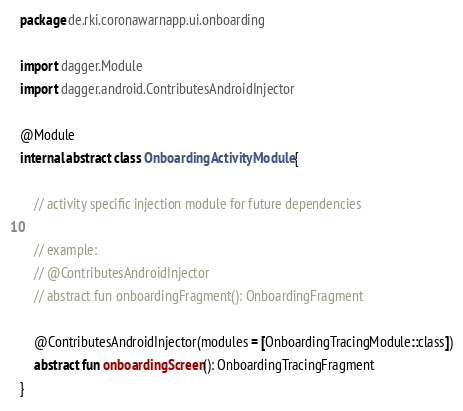Convert code to text. <code><loc_0><loc_0><loc_500><loc_500><_Kotlin_>package de.rki.coronawarnapp.ui.onboarding

import dagger.Module
import dagger.android.ContributesAndroidInjector

@Module
internal abstract class OnboardingActivityModule {

    // activity specific injection module for future dependencies

    // example:
    // @ContributesAndroidInjector
    // abstract fun onboardingFragment(): OnboardingFragment

    @ContributesAndroidInjector(modules = [OnboardingTracingModule::class])
    abstract fun onboardingScreen(): OnboardingTracingFragment
}
</code> 